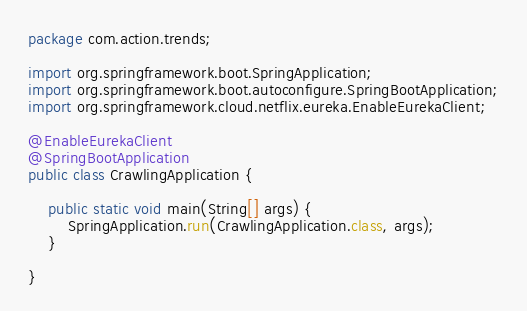Convert code to text. <code><loc_0><loc_0><loc_500><loc_500><_Java_>package com.action.trends;

import org.springframework.boot.SpringApplication;
import org.springframework.boot.autoconfigure.SpringBootApplication;
import org.springframework.cloud.netflix.eureka.EnableEurekaClient;

@EnableEurekaClient
@SpringBootApplication
public class CrawlingApplication {

	public static void main(String[] args) {
		SpringApplication.run(CrawlingApplication.class, args);
	}

}
</code> 